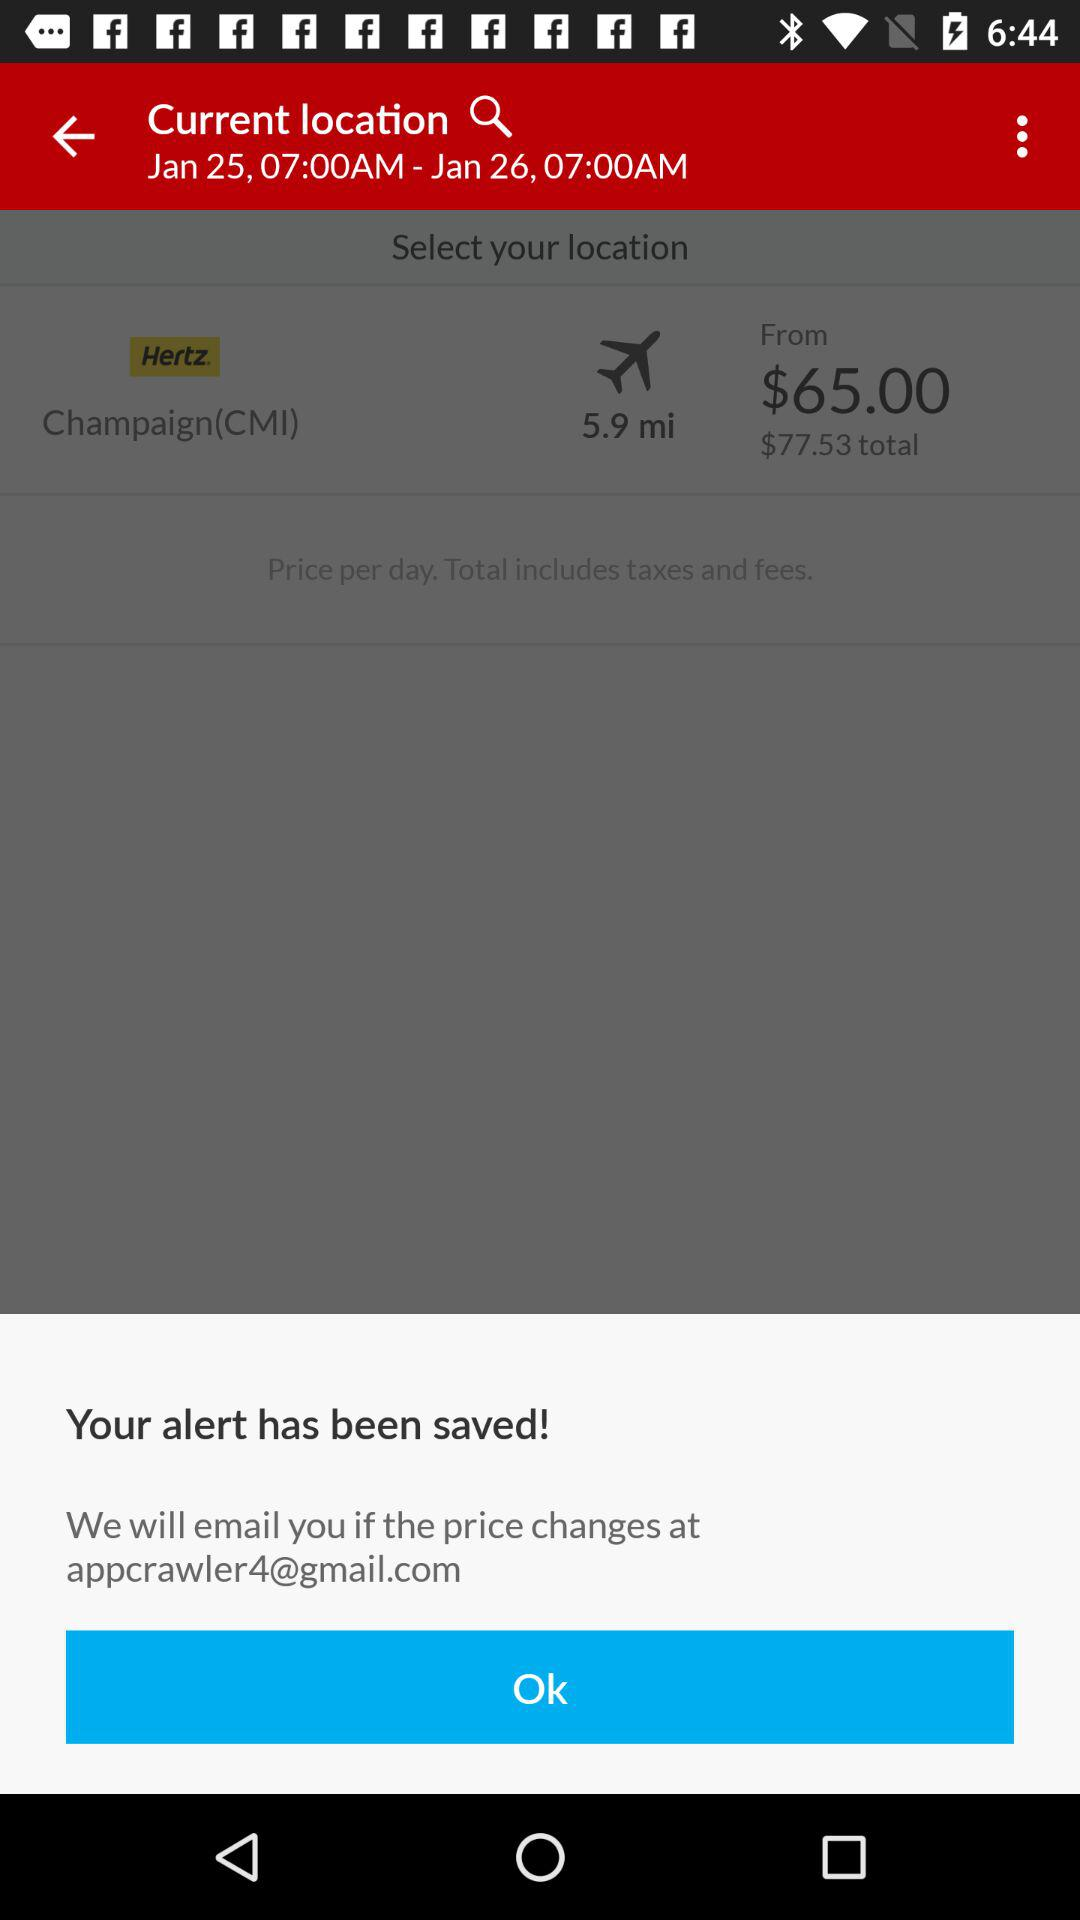How much more is the total than the price from?
Answer the question using a single word or phrase. $12.53 